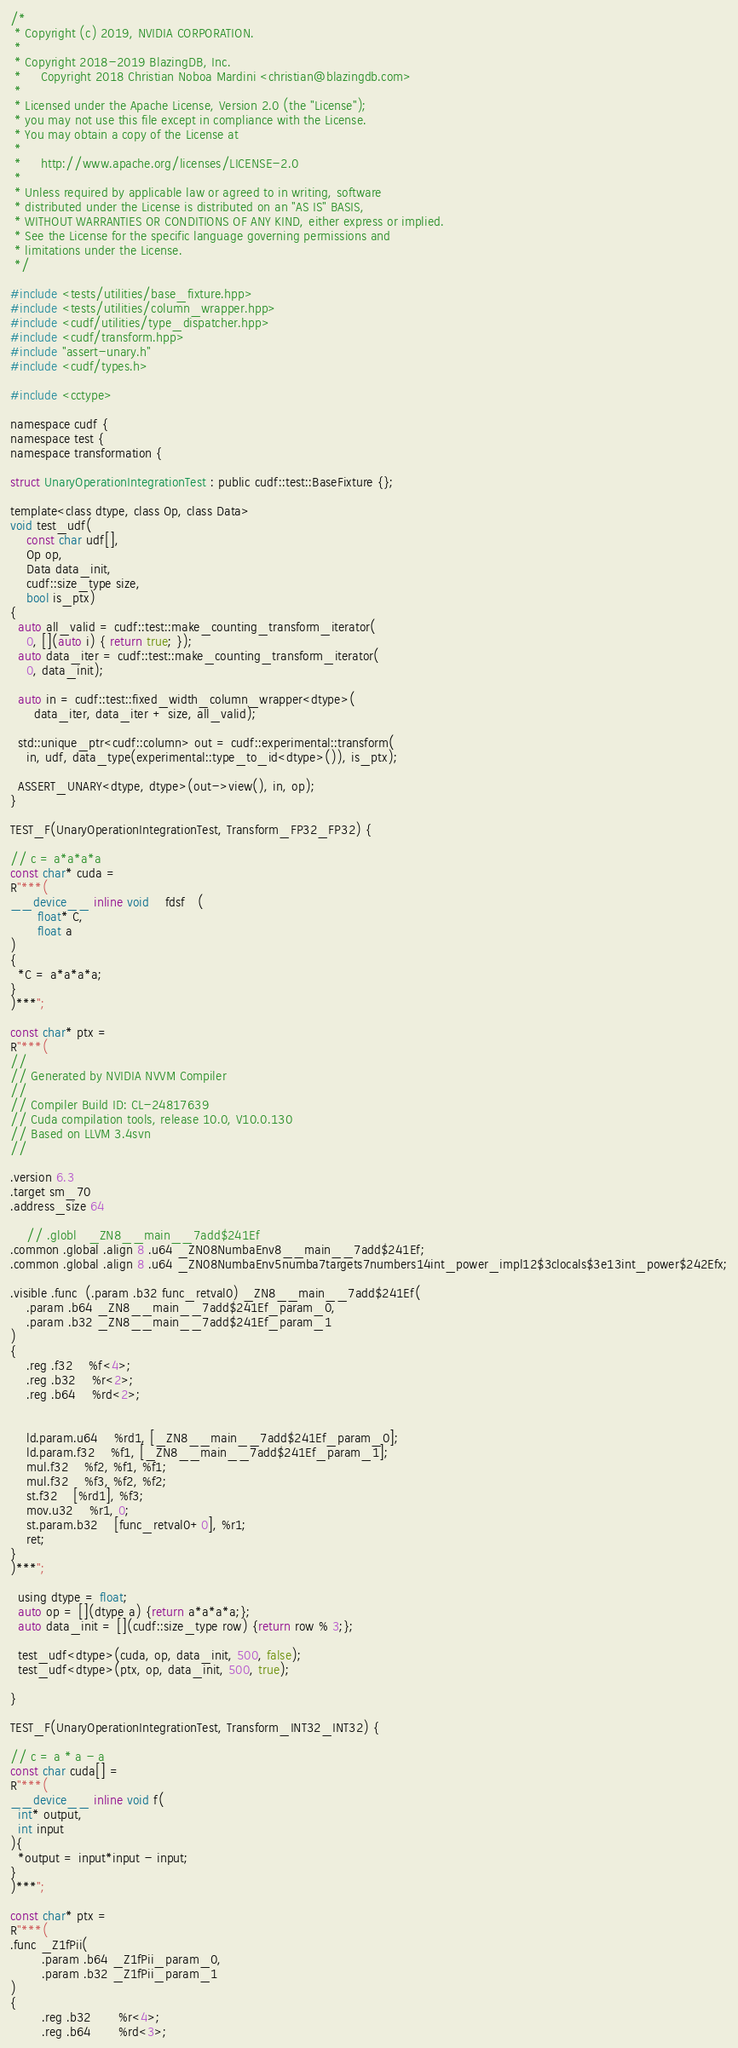Convert code to text. <code><loc_0><loc_0><loc_500><loc_500><_Cuda_>/*
 * Copyright (c) 2019, NVIDIA CORPORATION.
 *
 * Copyright 2018-2019 BlazingDB, Inc.
 *     Copyright 2018 Christian Noboa Mardini <christian@blazingdb.com>
 *
 * Licensed under the Apache License, Version 2.0 (the "License");
 * you may not use this file except in compliance with the License.
 * You may obtain a copy of the License at
 *
 *     http://www.apache.org/licenses/LICENSE-2.0
 *
 * Unless required by applicable law or agreed to in writing, software
 * distributed under the License is distributed on an "AS IS" BASIS,
 * WITHOUT WARRANTIES OR CONDITIONS OF ANY KIND, either express or implied.
 * See the License for the specific language governing permissions and
 * limitations under the License.
 */

#include <tests/utilities/base_fixture.hpp>
#include <tests/utilities/column_wrapper.hpp>
#include <cudf/utilities/type_dispatcher.hpp>
#include <cudf/transform.hpp>
#include "assert-unary.h"
#include <cudf/types.h>

#include <cctype>

namespace cudf {
namespace test {
namespace transformation {

struct UnaryOperationIntegrationTest : public cudf::test::BaseFixture {};

template<class dtype, class Op, class Data>
void test_udf(
    const char udf[], 
    Op op, 
    Data data_init, 
    cudf::size_type size,
    bool is_ptx)
{
  auto all_valid = cudf::test::make_counting_transform_iterator(
    0, [](auto i) { return true; });
  auto data_iter = cudf::test::make_counting_transform_iterator(
    0, data_init);

  auto in = cudf::test::fixed_width_column_wrapper<dtype>(
      data_iter, data_iter + size, all_valid);

  std::unique_ptr<cudf::column> out = cudf::experimental::transform(
    in, udf, data_type(experimental::type_to_id<dtype>()), is_ptx);

  ASSERT_UNARY<dtype, dtype>(out->view(), in, op);
}

TEST_F(UnaryOperationIntegrationTest, Transform_FP32_FP32) {

// c = a*a*a*a
const char* cuda =
R"***(
__device__ inline void    fdsf   (
       float* C,
       float a
)
{
  *C = a*a*a*a;
}
)***";

const char* ptx =
R"***(
//
// Generated by NVIDIA NVVM Compiler
//
// Compiler Build ID: CL-24817639
// Cuda compilation tools, release 10.0, V10.0.130
// Based on LLVM 3.4svn
//

.version 6.3
.target sm_70
.address_size 64

	// .globl	_ZN8__main__7add$241Ef
.common .global .align 8 .u64 _ZN08NumbaEnv8__main__7add$241Ef;
.common .global .align 8 .u64 _ZN08NumbaEnv5numba7targets7numbers14int_power_impl12$3clocals$3e13int_power$242Efx;

.visible .func  (.param .b32 func_retval0) _ZN8__main__7add$241Ef(
	.param .b64 _ZN8__main__7add$241Ef_param_0,
	.param .b32 _ZN8__main__7add$241Ef_param_1
)
{
	.reg .f32 	%f<4>;
	.reg .b32 	%r<2>;
	.reg .b64 	%rd<2>;


	ld.param.u64 	%rd1, [_ZN8__main__7add$241Ef_param_0];
	ld.param.f32 	%f1, [_ZN8__main__7add$241Ef_param_1];
	mul.f32 	%f2, %f1, %f1;
	mul.f32 	%f3, %f2, %f2;
	st.f32 	[%rd1], %f3;
	mov.u32 	%r1, 0;
	st.param.b32	[func_retval0+0], %r1;
	ret;
}
)***";

  using dtype = float;
  auto op = [](dtype a) {return a*a*a*a;};
  auto data_init = [](cudf::size_type row) {return row % 3;};
  
  test_udf<dtype>(cuda, op, data_init, 500, false);
  test_udf<dtype>(ptx, op, data_init, 500, true);

}

TEST_F(UnaryOperationIntegrationTest, Transform_INT32_INT32) {

// c = a * a - a
const char cuda[] =
R"***(
__device__ inline void f(
  int* output, 
  int input
){
  *output = input*input - input;
}
)***";

const char* ptx =
R"***(
.func _Z1fPii(
        .param .b64 _Z1fPii_param_0,
        .param .b32 _Z1fPii_param_1
)
{
        .reg .b32       %r<4>;
        .reg .b64       %rd<3>;

</code> 